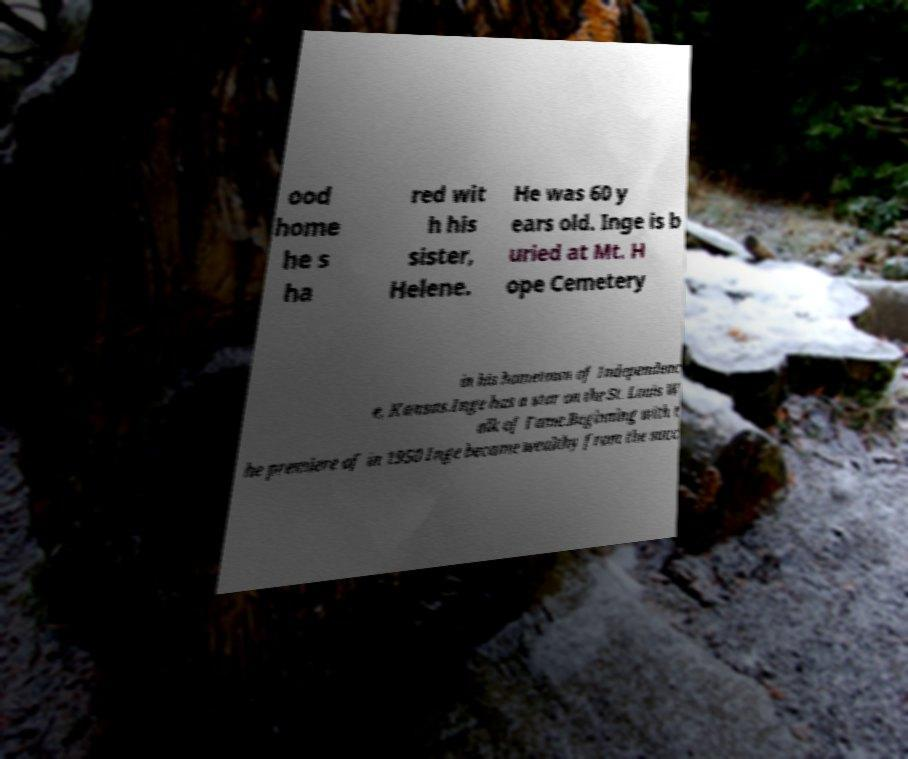Please identify and transcribe the text found in this image. ood home he s ha red wit h his sister, Helene. He was 60 y ears old. Inge is b uried at Mt. H ope Cemetery in his hometown of Independenc e, Kansas.Inge has a star on the St. Louis W alk of Fame.Beginning with t he premiere of in 1950 Inge became wealthy from the succ 